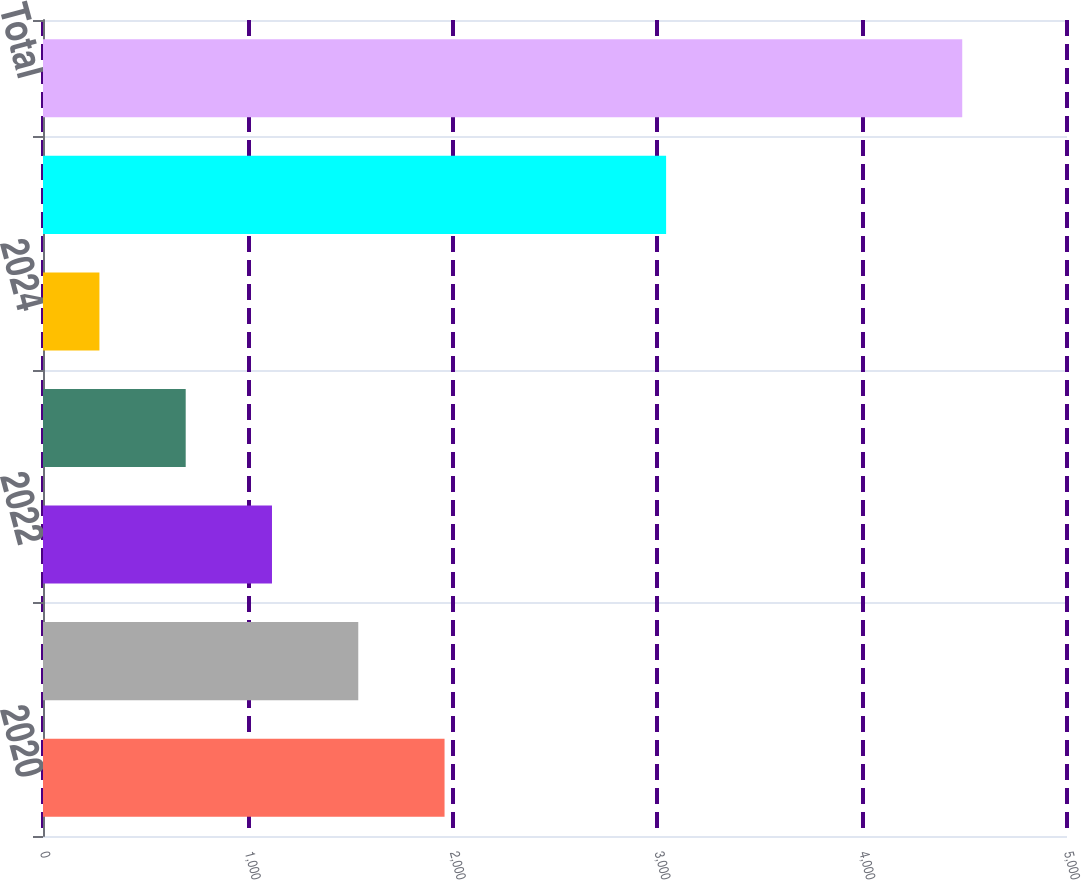Convert chart to OTSL. <chart><loc_0><loc_0><loc_500><loc_500><bar_chart><fcel>2020<fcel>2021<fcel>2022<fcel>2023<fcel>2024<fcel>Thereafter<fcel>Total<nl><fcel>1960.7<fcel>1539.4<fcel>1118.1<fcel>696.8<fcel>275.5<fcel>3042.5<fcel>4488.5<nl></chart> 